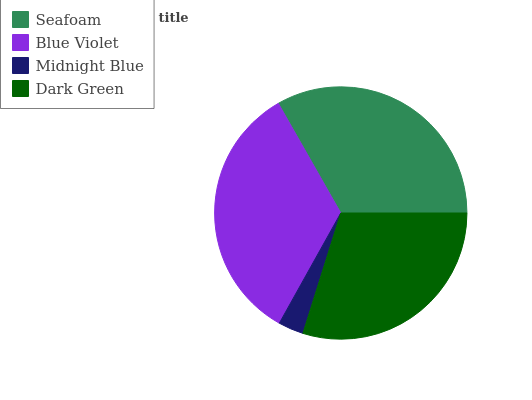Is Midnight Blue the minimum?
Answer yes or no. Yes. Is Blue Violet the maximum?
Answer yes or no. Yes. Is Blue Violet the minimum?
Answer yes or no. No. Is Midnight Blue the maximum?
Answer yes or no. No. Is Blue Violet greater than Midnight Blue?
Answer yes or no. Yes. Is Midnight Blue less than Blue Violet?
Answer yes or no. Yes. Is Midnight Blue greater than Blue Violet?
Answer yes or no. No. Is Blue Violet less than Midnight Blue?
Answer yes or no. No. Is Seafoam the high median?
Answer yes or no. Yes. Is Dark Green the low median?
Answer yes or no. Yes. Is Blue Violet the high median?
Answer yes or no. No. Is Midnight Blue the low median?
Answer yes or no. No. 